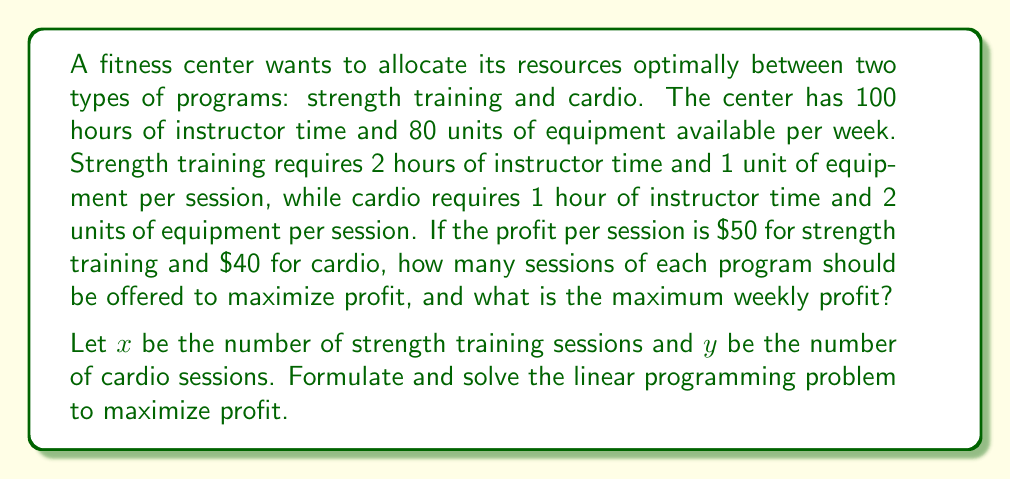Provide a solution to this math problem. To solve this linear programming problem, we'll follow these steps:

1. Define the objective function:
   Maximize $Z = 50x + 40y$

2. Identify the constraints:
   Instructor time: $2x + y \leq 100$
   Equipment: $x + 2y \leq 80$
   Non-negativity: $x \geq 0, y \geq 0$

3. Graph the constraints:
   [asy]
   import geometry;
   
   size(200);
   
   xlimits(0, 100);
   ylimits(0, 100);
   
   xaxis("x", Arrow);
   yaxis("y", Arrow);
   
   draw((0,100)--(50,0), blue);
   draw((0,40)--(80,0), red);
   
   label("2x + y = 100", (25,50), N, blue);
   label("x + 2y = 80", (40,20), SE, red);
   
   fill((0,0)--(0,40)--(26.67,26.67)--(50,0)--cycle, lightgray);
   
   dot((0,40));
   dot((50,0));
   dot((26.67,26.67));
   
   label("(0,40)", (0,40), W);
   label("(50,0)", (50,0), S);
   label("(26.67,26.67)", (26.67,26.67), NE);
   [/asy]

4. Identify the vertices of the feasible region:
   (0,0), (0,40), (26.67,26.67), (50,0)

5. Evaluate the objective function at each vertex:
   At (0,0): $Z = 0$
   At (0,40): $Z = 40 * 40 = 1600$
   At (26.67,26.67): $Z = 50 * 26.67 + 40 * 26.67 = 2400$
   At (50,0): $Z = 50 * 50 = 2500$

6. The maximum profit occurs at (50,0), which means offering 50 strength training sessions and 0 cardio sessions.

7. Calculate the maximum weekly profit:
   $Z_{max} = 50 * 50 + 40 * 0 = 2500$
Answer: 50 strength training sessions, 0 cardio sessions; $2500 maximum weekly profit 